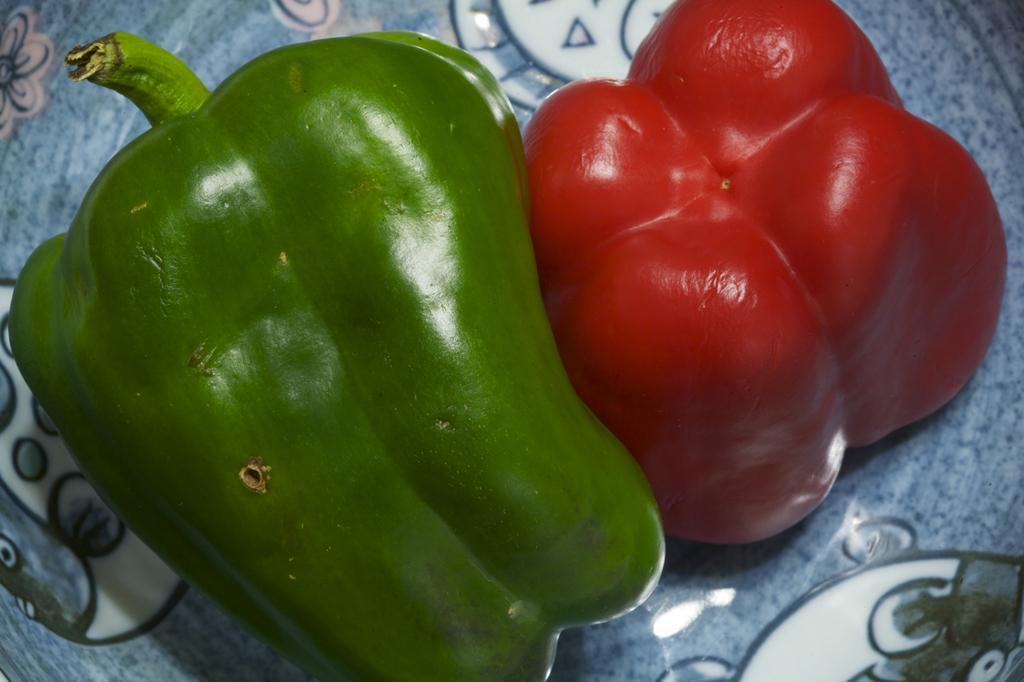Please provide a concise description of this image. We can see green and red color peppers on surface. 